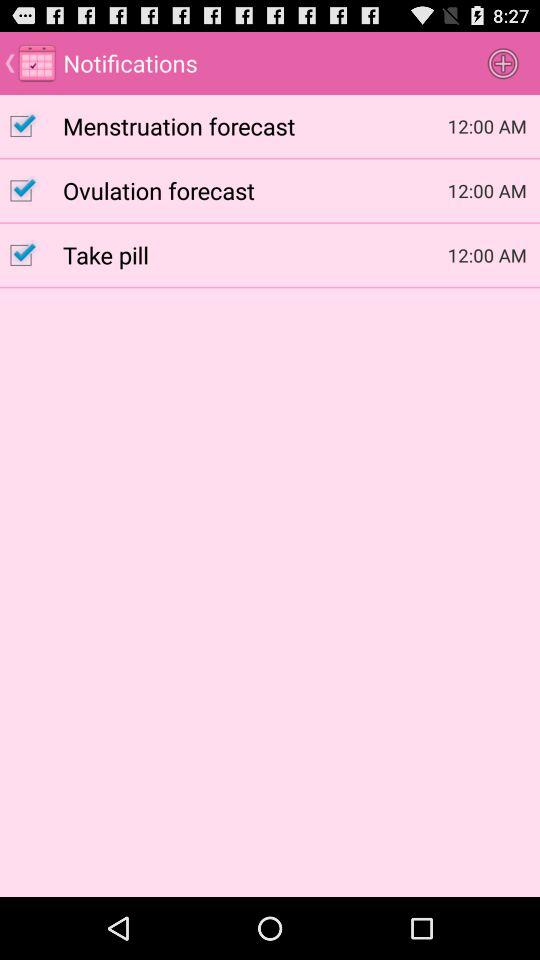What is the status of the "Menstruation forecast"? The status is "on". 